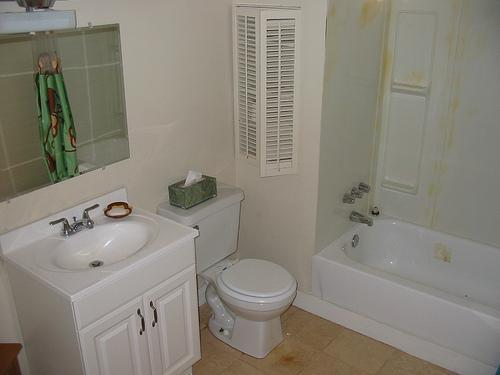How many bars of soap are visible?
Give a very brief answer. 1. How many types of soap are on the counter?
Give a very brief answer. 1. How many people are not on the working truck?
Give a very brief answer. 0. 